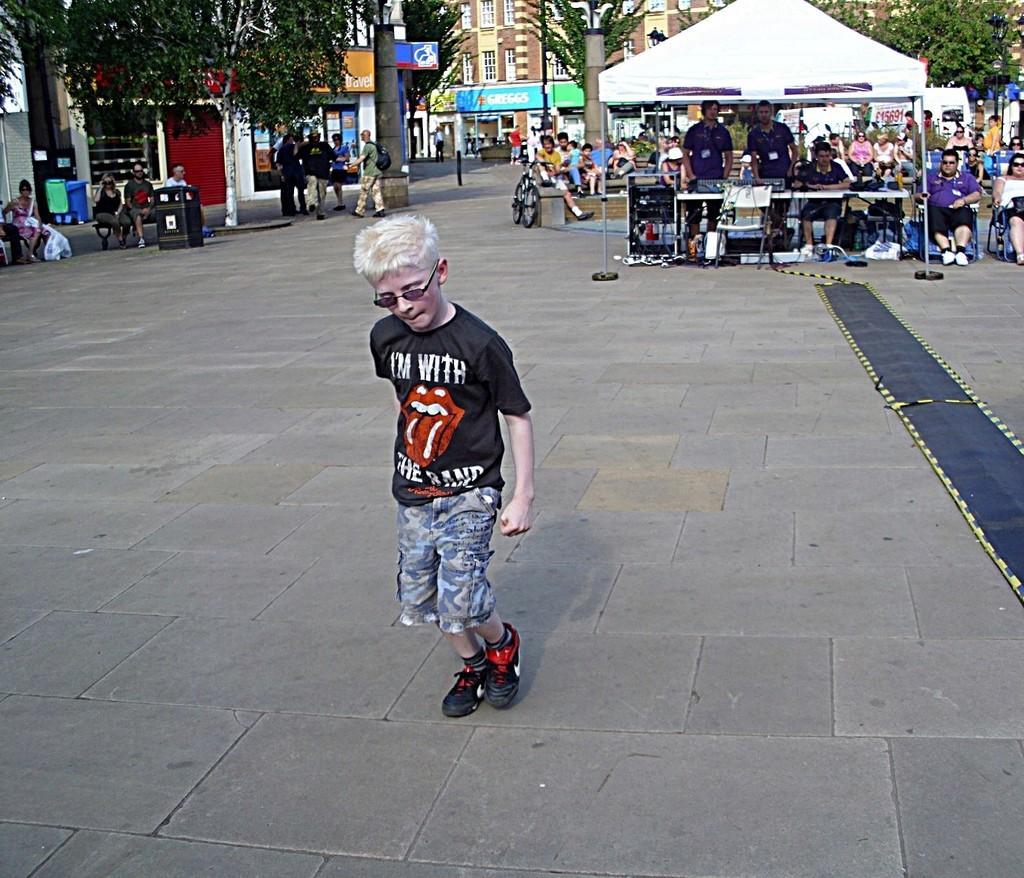In one or two sentences, can you explain what this image depicts? In this image we can see a boy is standing on the road, he is wearing black color t-shirt with shorts. Background of the image so many people are sitting, walking, standing. And trees, buildings are there. 